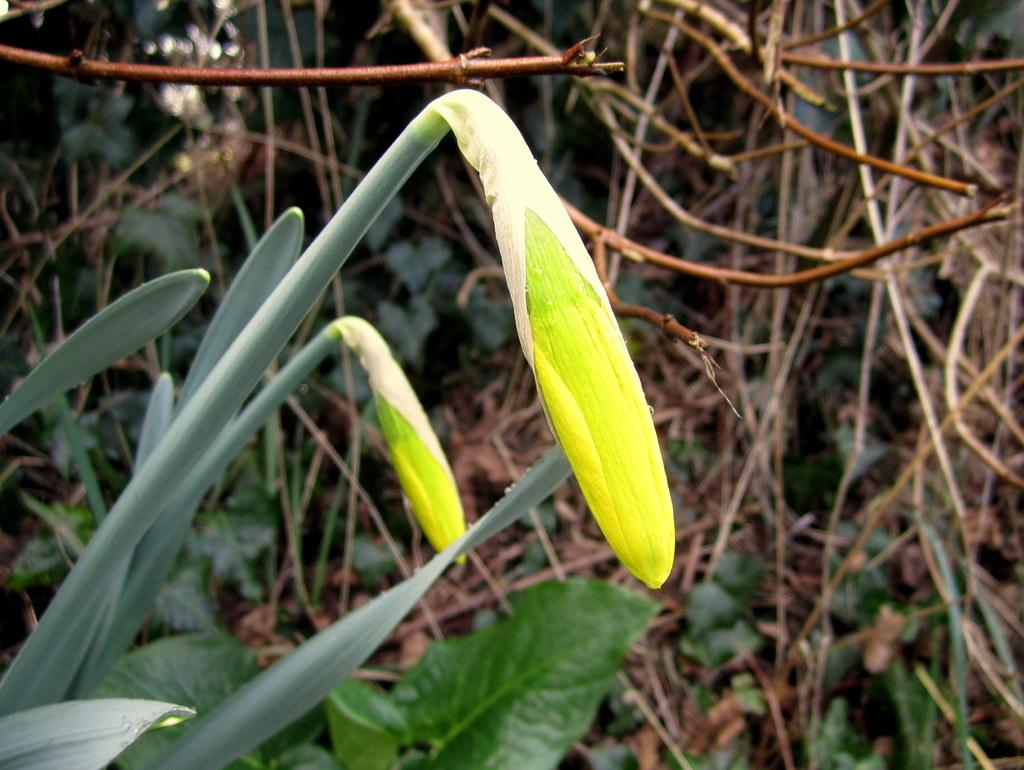What stage of growth are the plants in the image at? The plants in the image have buds, indicating they are in an early stage of growth. Can you describe the plants in the background of the image? The plants in the background are not specified in the facts, but we know they are present. What might be the next stage of growth for the plants with buds? The next stage of growth for the plants with buds would likely be the development of flowers or leaves. What type of vessel is being used to transport the plants in the image? There is no vessel present in the image; it features plants with buds and plants in the background. What is the primary interest of the plants in the image? Plants do not have interests; they are living organisms that grow and reproduce. 